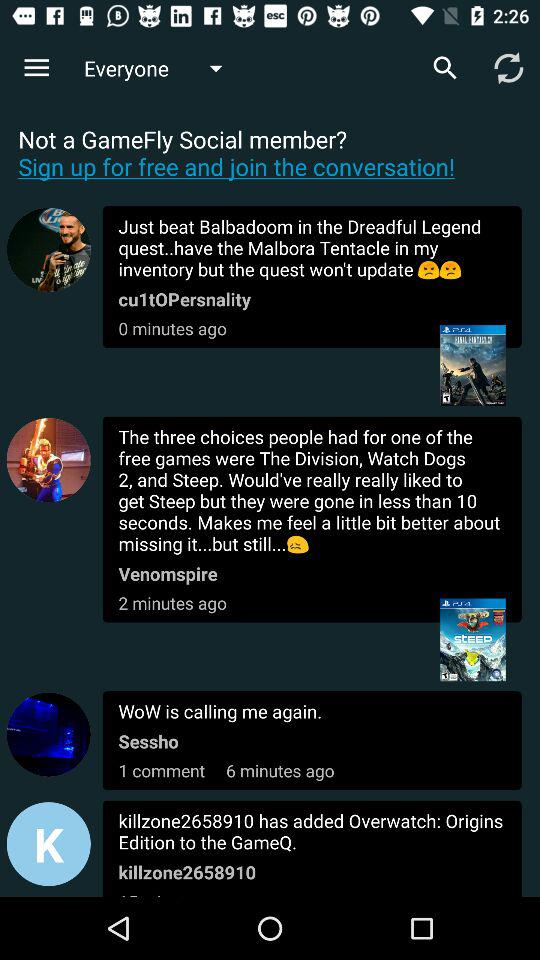At what time did "Venomspire" text the message? "Venomspire" texted the message 2 minutes ago. 